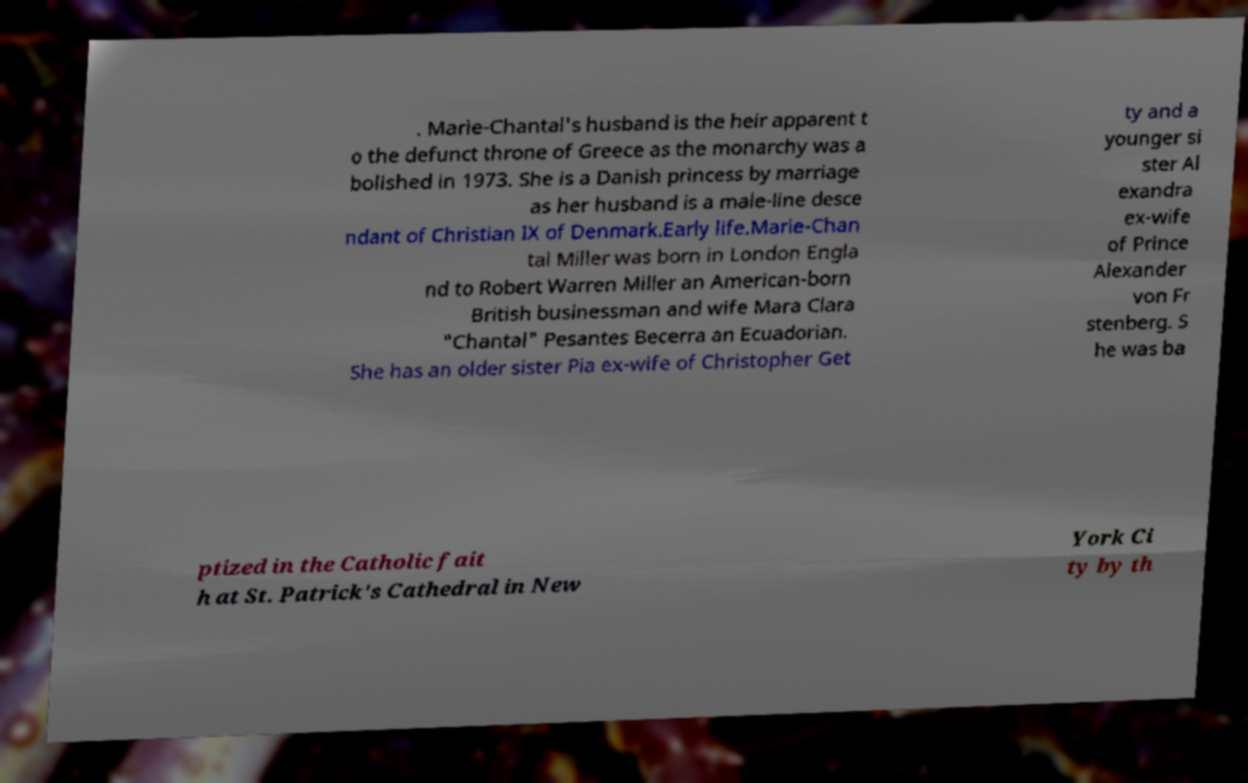I need the written content from this picture converted into text. Can you do that? . Marie-Chantal's husband is the heir apparent t o the defunct throne of Greece as the monarchy was a bolished in 1973. She is a Danish princess by marriage as her husband is a male-line desce ndant of Christian IX of Denmark.Early life.Marie-Chan tal Miller was born in London Engla nd to Robert Warren Miller an American-born British businessman and wife Mara Clara "Chantal" Pesantes Becerra an Ecuadorian. She has an older sister Pia ex-wife of Christopher Get ty and a younger si ster Al exandra ex-wife of Prince Alexander von Fr stenberg. S he was ba ptized in the Catholic fait h at St. Patrick's Cathedral in New York Ci ty by th 